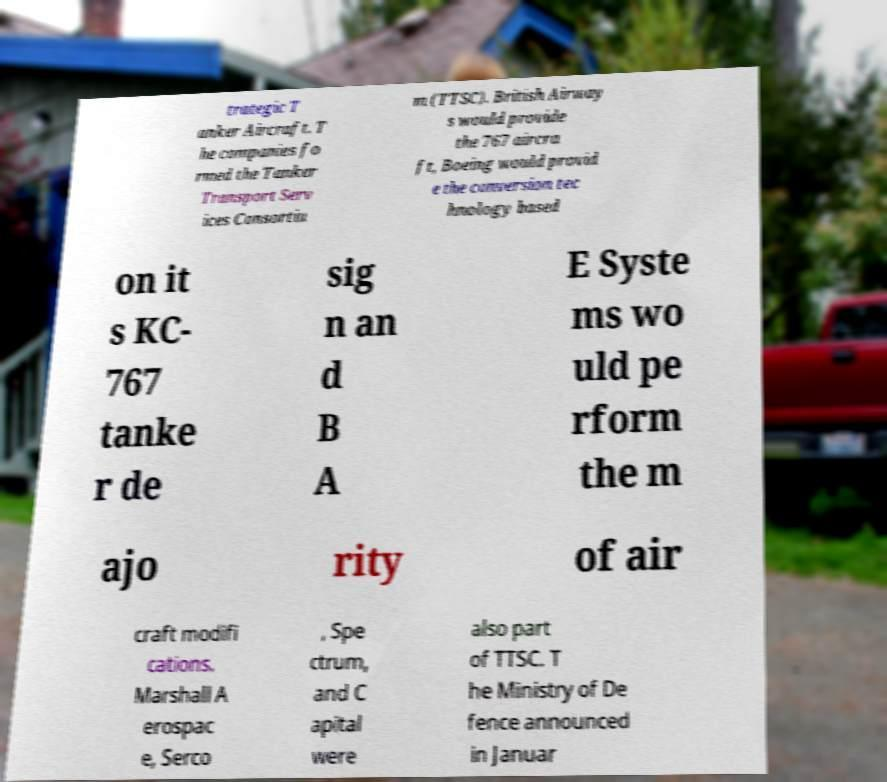Can you accurately transcribe the text from the provided image for me? trategic T anker Aircraft. T he companies fo rmed the Tanker Transport Serv ices Consortiu m (TTSC). British Airway s would provide the 767 aircra ft, Boeing would provid e the conversion tec hnology based on it s KC- 767 tanke r de sig n an d B A E Syste ms wo uld pe rform the m ajo rity of air craft modifi cations. Marshall A erospac e, Serco , Spe ctrum, and C apital were also part of TTSC. T he Ministry of De fence announced in Januar 